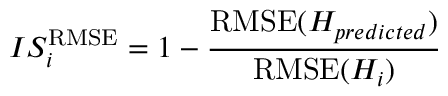Convert formula to latex. <formula><loc_0><loc_0><loc_500><loc_500>{ I S _ { i } ^ { R M S E } = 1 - \frac { R M S E ( H _ { p r e d i c t e d } ) } { R M S E ( H _ { i } ) } }</formula> 